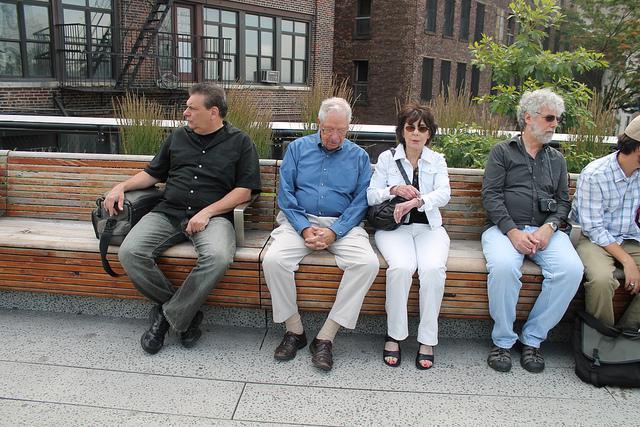How many men are in this image?
Give a very brief answer. 4. How many people wearing glasses?
Give a very brief answer. 2. How many handbags are visible?
Give a very brief answer. 2. How many people are in the photo?
Give a very brief answer. 5. How many benches are there?
Give a very brief answer. 2. How many clocks can be seen?
Give a very brief answer. 0. 